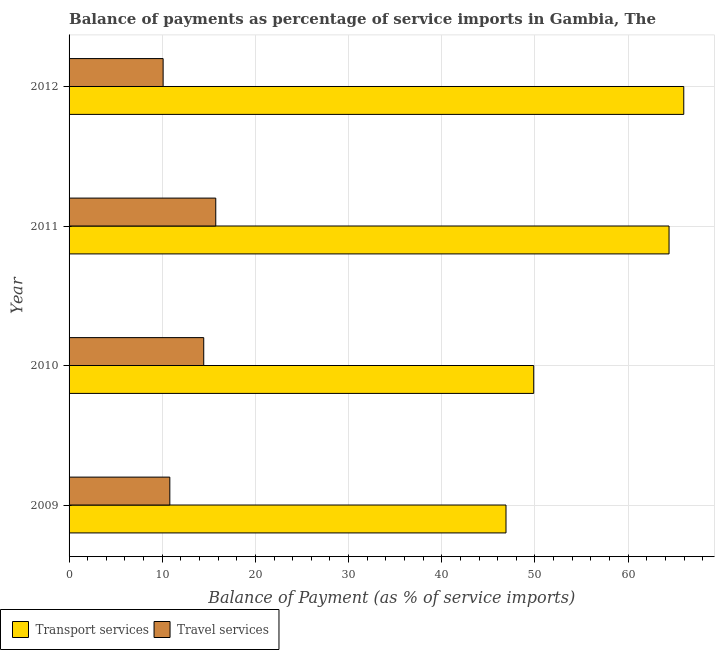How many groups of bars are there?
Offer a terse response. 4. Are the number of bars per tick equal to the number of legend labels?
Provide a succinct answer. Yes. What is the label of the 2nd group of bars from the top?
Your answer should be very brief. 2011. What is the balance of payments of travel services in 2009?
Offer a very short reply. 10.81. Across all years, what is the maximum balance of payments of travel services?
Provide a succinct answer. 15.74. Across all years, what is the minimum balance of payments of travel services?
Provide a succinct answer. 10.09. In which year was the balance of payments of transport services minimum?
Give a very brief answer. 2009. What is the total balance of payments of transport services in the graph?
Keep it short and to the point. 227.12. What is the difference between the balance of payments of travel services in 2010 and that in 2012?
Ensure brevity in your answer.  4.36. What is the difference between the balance of payments of transport services in 2011 and the balance of payments of travel services in 2010?
Ensure brevity in your answer.  49.94. What is the average balance of payments of travel services per year?
Keep it short and to the point. 12.78. In the year 2010, what is the difference between the balance of payments of travel services and balance of payments of transport services?
Offer a terse response. -35.41. What is the ratio of the balance of payments of transport services in 2009 to that in 2011?
Offer a terse response. 0.73. Is the difference between the balance of payments of transport services in 2009 and 2012 greater than the difference between the balance of payments of travel services in 2009 and 2012?
Ensure brevity in your answer.  No. What is the difference between the highest and the second highest balance of payments of transport services?
Make the answer very short. 1.58. What is the difference between the highest and the lowest balance of payments of transport services?
Keep it short and to the point. 19.08. In how many years, is the balance of payments of transport services greater than the average balance of payments of transport services taken over all years?
Your answer should be very brief. 2. What does the 1st bar from the top in 2011 represents?
Offer a very short reply. Travel services. What does the 1st bar from the bottom in 2009 represents?
Offer a terse response. Transport services. How many years are there in the graph?
Your response must be concise. 4. What is the difference between two consecutive major ticks on the X-axis?
Offer a very short reply. 10. Does the graph contain grids?
Ensure brevity in your answer.  Yes. Where does the legend appear in the graph?
Your answer should be compact. Bottom left. How are the legend labels stacked?
Give a very brief answer. Horizontal. What is the title of the graph?
Your response must be concise. Balance of payments as percentage of service imports in Gambia, The. Does "Under five" appear as one of the legend labels in the graph?
Offer a terse response. No. What is the label or title of the X-axis?
Make the answer very short. Balance of Payment (as % of service imports). What is the Balance of Payment (as % of service imports) in Transport services in 2009?
Make the answer very short. 46.89. What is the Balance of Payment (as % of service imports) of Travel services in 2009?
Ensure brevity in your answer.  10.81. What is the Balance of Payment (as % of service imports) of Transport services in 2010?
Offer a very short reply. 49.87. What is the Balance of Payment (as % of service imports) of Travel services in 2010?
Your answer should be very brief. 14.45. What is the Balance of Payment (as % of service imports) in Transport services in 2011?
Provide a succinct answer. 64.39. What is the Balance of Payment (as % of service imports) of Travel services in 2011?
Keep it short and to the point. 15.74. What is the Balance of Payment (as % of service imports) in Transport services in 2012?
Your answer should be very brief. 65.97. What is the Balance of Payment (as % of service imports) of Travel services in 2012?
Give a very brief answer. 10.09. Across all years, what is the maximum Balance of Payment (as % of service imports) of Transport services?
Ensure brevity in your answer.  65.97. Across all years, what is the maximum Balance of Payment (as % of service imports) of Travel services?
Provide a succinct answer. 15.74. Across all years, what is the minimum Balance of Payment (as % of service imports) of Transport services?
Ensure brevity in your answer.  46.89. Across all years, what is the minimum Balance of Payment (as % of service imports) of Travel services?
Make the answer very short. 10.09. What is the total Balance of Payment (as % of service imports) of Transport services in the graph?
Keep it short and to the point. 227.12. What is the total Balance of Payment (as % of service imports) of Travel services in the graph?
Your answer should be compact. 51.1. What is the difference between the Balance of Payment (as % of service imports) of Transport services in 2009 and that in 2010?
Provide a short and direct response. -2.98. What is the difference between the Balance of Payment (as % of service imports) in Travel services in 2009 and that in 2010?
Your response must be concise. -3.64. What is the difference between the Balance of Payment (as % of service imports) of Transport services in 2009 and that in 2011?
Your answer should be very brief. -17.5. What is the difference between the Balance of Payment (as % of service imports) in Travel services in 2009 and that in 2011?
Offer a very short reply. -4.93. What is the difference between the Balance of Payment (as % of service imports) of Transport services in 2009 and that in 2012?
Your answer should be very brief. -19.08. What is the difference between the Balance of Payment (as % of service imports) in Travel services in 2009 and that in 2012?
Keep it short and to the point. 0.72. What is the difference between the Balance of Payment (as % of service imports) in Transport services in 2010 and that in 2011?
Offer a terse response. -14.52. What is the difference between the Balance of Payment (as % of service imports) of Travel services in 2010 and that in 2011?
Your response must be concise. -1.29. What is the difference between the Balance of Payment (as % of service imports) of Transport services in 2010 and that in 2012?
Your response must be concise. -16.1. What is the difference between the Balance of Payment (as % of service imports) of Travel services in 2010 and that in 2012?
Your answer should be very brief. 4.36. What is the difference between the Balance of Payment (as % of service imports) of Transport services in 2011 and that in 2012?
Provide a short and direct response. -1.58. What is the difference between the Balance of Payment (as % of service imports) of Travel services in 2011 and that in 2012?
Provide a short and direct response. 5.65. What is the difference between the Balance of Payment (as % of service imports) of Transport services in 2009 and the Balance of Payment (as % of service imports) of Travel services in 2010?
Your response must be concise. 32.44. What is the difference between the Balance of Payment (as % of service imports) in Transport services in 2009 and the Balance of Payment (as % of service imports) in Travel services in 2011?
Your response must be concise. 31.15. What is the difference between the Balance of Payment (as % of service imports) of Transport services in 2009 and the Balance of Payment (as % of service imports) of Travel services in 2012?
Offer a very short reply. 36.8. What is the difference between the Balance of Payment (as % of service imports) of Transport services in 2010 and the Balance of Payment (as % of service imports) of Travel services in 2011?
Give a very brief answer. 34.12. What is the difference between the Balance of Payment (as % of service imports) of Transport services in 2010 and the Balance of Payment (as % of service imports) of Travel services in 2012?
Provide a succinct answer. 39.77. What is the difference between the Balance of Payment (as % of service imports) of Transport services in 2011 and the Balance of Payment (as % of service imports) of Travel services in 2012?
Your answer should be compact. 54.3. What is the average Balance of Payment (as % of service imports) in Transport services per year?
Keep it short and to the point. 56.78. What is the average Balance of Payment (as % of service imports) of Travel services per year?
Ensure brevity in your answer.  12.78. In the year 2009, what is the difference between the Balance of Payment (as % of service imports) in Transport services and Balance of Payment (as % of service imports) in Travel services?
Provide a short and direct response. 36.08. In the year 2010, what is the difference between the Balance of Payment (as % of service imports) of Transport services and Balance of Payment (as % of service imports) of Travel services?
Give a very brief answer. 35.41. In the year 2011, what is the difference between the Balance of Payment (as % of service imports) in Transport services and Balance of Payment (as % of service imports) in Travel services?
Provide a short and direct response. 48.65. In the year 2012, what is the difference between the Balance of Payment (as % of service imports) of Transport services and Balance of Payment (as % of service imports) of Travel services?
Ensure brevity in your answer.  55.87. What is the ratio of the Balance of Payment (as % of service imports) of Transport services in 2009 to that in 2010?
Provide a succinct answer. 0.94. What is the ratio of the Balance of Payment (as % of service imports) of Travel services in 2009 to that in 2010?
Provide a short and direct response. 0.75. What is the ratio of the Balance of Payment (as % of service imports) in Transport services in 2009 to that in 2011?
Provide a short and direct response. 0.73. What is the ratio of the Balance of Payment (as % of service imports) in Travel services in 2009 to that in 2011?
Keep it short and to the point. 0.69. What is the ratio of the Balance of Payment (as % of service imports) of Transport services in 2009 to that in 2012?
Provide a short and direct response. 0.71. What is the ratio of the Balance of Payment (as % of service imports) in Travel services in 2009 to that in 2012?
Make the answer very short. 1.07. What is the ratio of the Balance of Payment (as % of service imports) in Transport services in 2010 to that in 2011?
Provide a short and direct response. 0.77. What is the ratio of the Balance of Payment (as % of service imports) in Travel services in 2010 to that in 2011?
Give a very brief answer. 0.92. What is the ratio of the Balance of Payment (as % of service imports) of Transport services in 2010 to that in 2012?
Keep it short and to the point. 0.76. What is the ratio of the Balance of Payment (as % of service imports) in Travel services in 2010 to that in 2012?
Your answer should be compact. 1.43. What is the ratio of the Balance of Payment (as % of service imports) in Transport services in 2011 to that in 2012?
Give a very brief answer. 0.98. What is the ratio of the Balance of Payment (as % of service imports) in Travel services in 2011 to that in 2012?
Provide a succinct answer. 1.56. What is the difference between the highest and the second highest Balance of Payment (as % of service imports) in Transport services?
Offer a very short reply. 1.58. What is the difference between the highest and the second highest Balance of Payment (as % of service imports) in Travel services?
Provide a succinct answer. 1.29. What is the difference between the highest and the lowest Balance of Payment (as % of service imports) of Transport services?
Ensure brevity in your answer.  19.08. What is the difference between the highest and the lowest Balance of Payment (as % of service imports) in Travel services?
Ensure brevity in your answer.  5.65. 